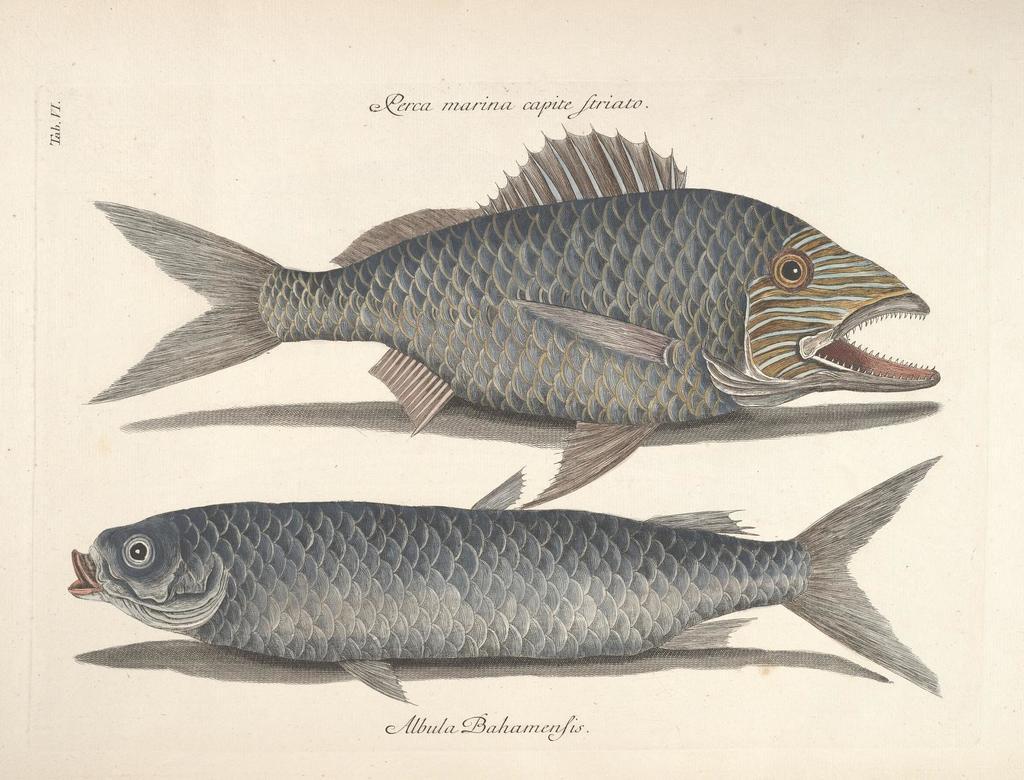Can you describe this image briefly? This looks like a paper. I can see two different types of fishes. These are the letters on the paper. 